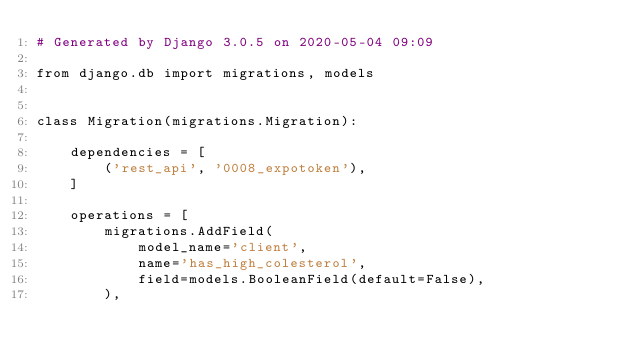Convert code to text. <code><loc_0><loc_0><loc_500><loc_500><_Python_># Generated by Django 3.0.5 on 2020-05-04 09:09

from django.db import migrations, models


class Migration(migrations.Migration):

    dependencies = [
        ('rest_api', '0008_expotoken'),
    ]

    operations = [
        migrations.AddField(
            model_name='client',
            name='has_high_colesterol',
            field=models.BooleanField(default=False),
        ),</code> 